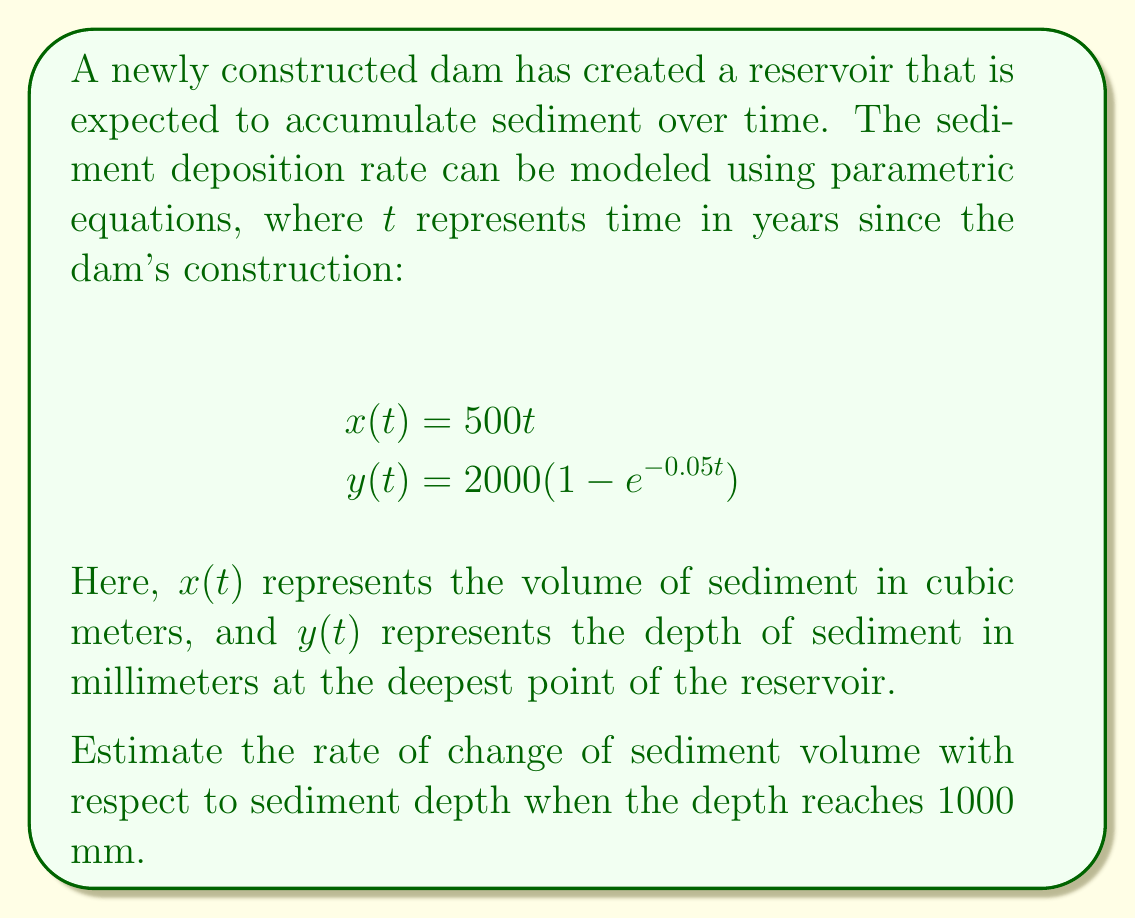Give your solution to this math problem. To solve this problem, we need to follow these steps:

1) First, we need to find the time $t$ when the sediment depth reaches 1000 mm. We can do this by solving the equation:

   $$1000 = 2000(1 - e^{-0.05t})$$

2) Solving for $t$:
   
   $$0.5 = 1 - e^{-0.05t}$$
   $$e^{-0.05t} = 0.5$$
   $$-0.05t = \ln(0.5)$$
   $$t = -\frac{\ln(0.5)}{0.05} \approx 13.86 \text{ years}$$

3) Now that we know $t$, we can calculate $\frac{dx}{dt}$ and $\frac{dy}{dt}$ at this time:

   $$\frac{dx}{dt} = 500 \text{ (constant)}$$
   
   $$\frac{dy}{dt} = 2000 \cdot 0.05e^{-0.05t} = 100e^{-0.05t}$$

4) At $t \approx 13.86$ years:
   
   $$\frac{dy}{dt} = 100e^{-0.05(13.86)} \approx 50 \text{ mm/year}$$

5) The rate of change of sediment volume with respect to sediment depth is given by:

   $$\frac{dx}{dy} = \frac{dx/dt}{dy/dt}$$

6) Substituting the values we found:

   $$\frac{dx}{dy} = \frac{500}{50} = 10 \text{ m}^3\text{/mm}$$

This means that when the sediment depth is 1000 mm, for each additional millimeter of depth, the sediment volume increases by 10 cubic meters.
Answer: The rate of change of sediment volume with respect to sediment depth when the depth reaches 1000 mm is approximately $10 \text{ m}^3\text{/mm}$. 